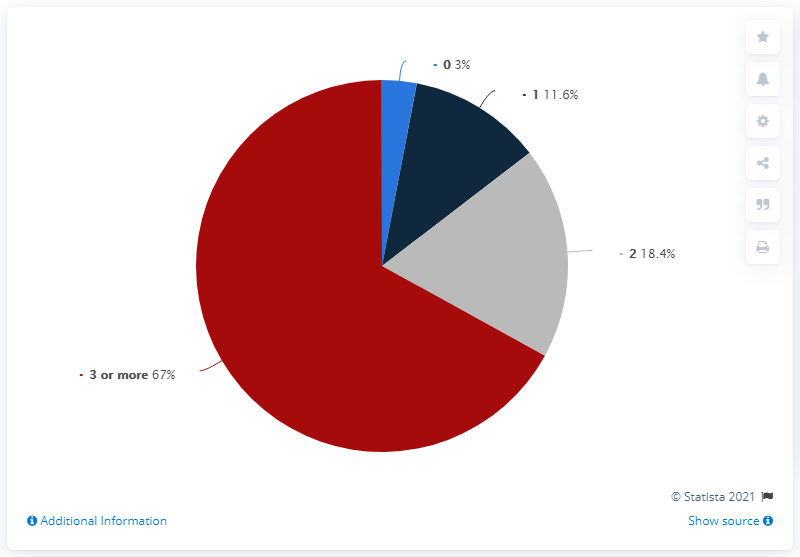Highlight a few significant elements in this photo. As of April 28, 2021, there were 67 comorbidities observed in COVID-19 deceased patients in Italy, where the number of comorbidities was greater than 3. As of April 28, 2021, in Italy, the total percentage of COVID-19 deceased patients with two or more comorbidities was found to be 85.4%. 